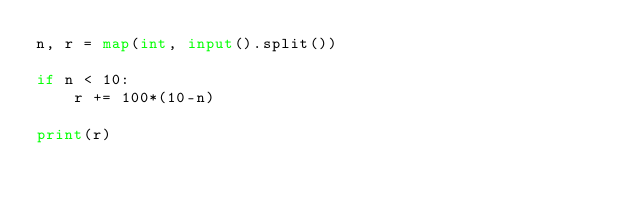Convert code to text. <code><loc_0><loc_0><loc_500><loc_500><_Python_>n, r = map(int, input().split())

if n < 10:
    r += 100*(10-n)

print(r)</code> 